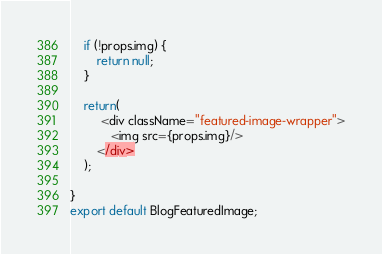<code> <loc_0><loc_0><loc_500><loc_500><_JavaScript_>    if (!props.img) {
        return null;
    }

    return(
         <div className="featured-image-wrapper">
            <img src={props.img}/>
        </div>
    );

}
export default BlogFeaturedImage;</code> 